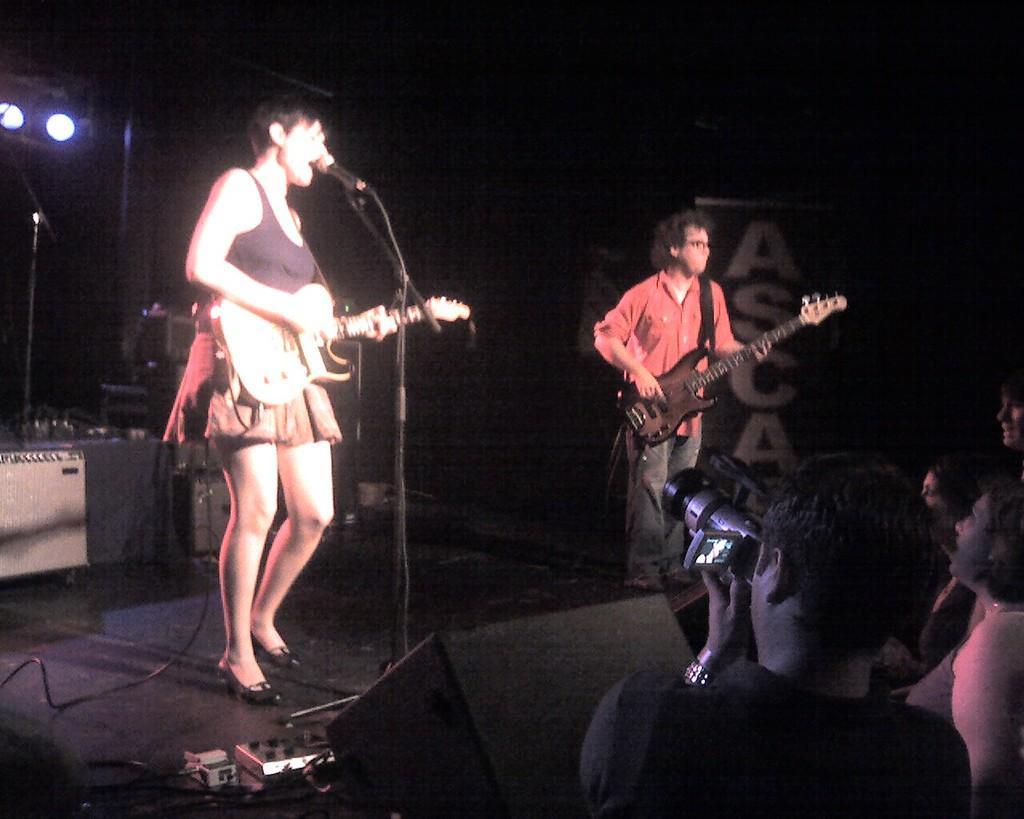Please provide a concise description of this image. There is a woman standing on a stage, she is playing and she is signing and a man is playing guitar. There is a speaker and a microphone on the stage. At the bottom of the image there is a Person holding camera and at the top of the image there is a light. 